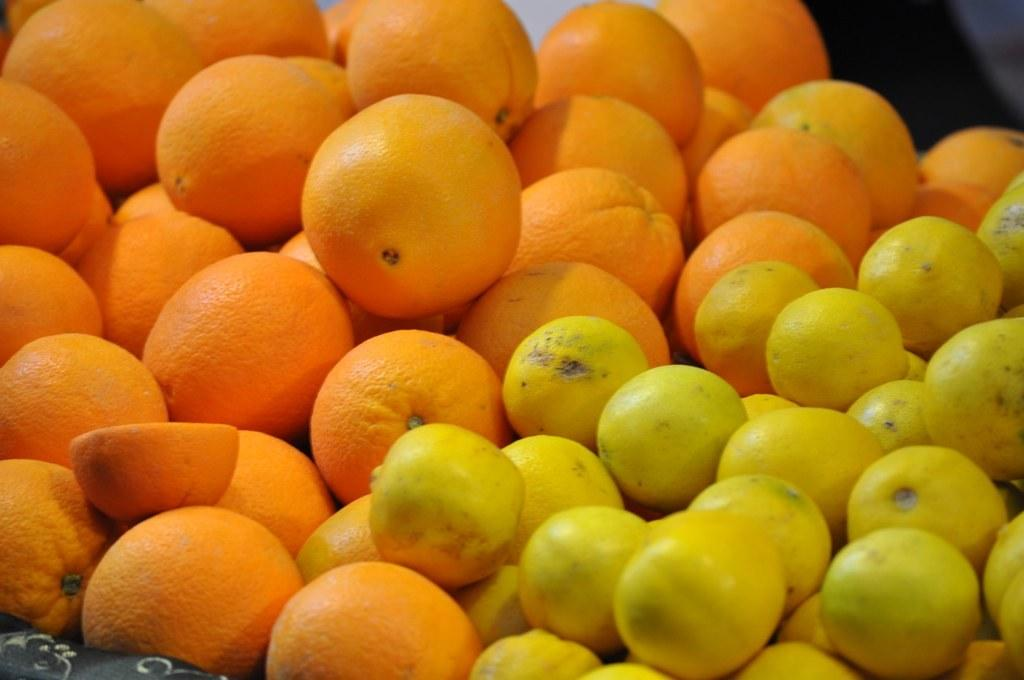What type of fruit can be seen in the image? There are oranges and lemons in the image. Can you describe the color of the oranges? The oranges in the image are typically orange in color. What other type of fruit is present in the image? There are lemons in the image as well. Can you describe the color of the lemons? The lemons in the image are typically yellow in color. What type of whistle can be heard during the party at the church in the image? There is no whistle, party, or church present in the image; it only features oranges and lemons. 